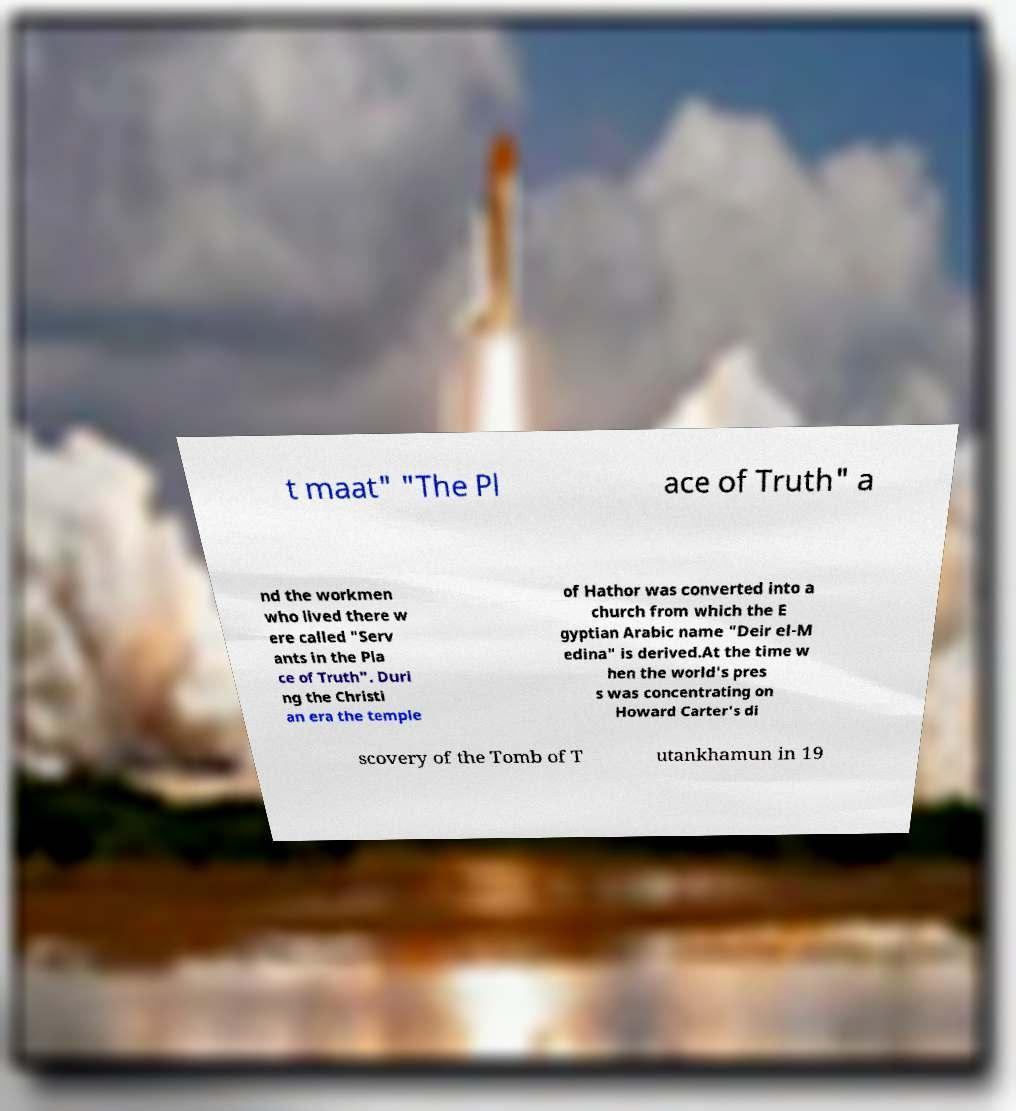Please identify and transcribe the text found in this image. t maat" "The Pl ace of Truth" a nd the workmen who lived there w ere called "Serv ants in the Pla ce of Truth". Duri ng the Christi an era the temple of Hathor was converted into a church from which the E gyptian Arabic name "Deir el-M edina" is derived.At the time w hen the world's pres s was concentrating on Howard Carter's di scovery of the Tomb of T utankhamun in 19 